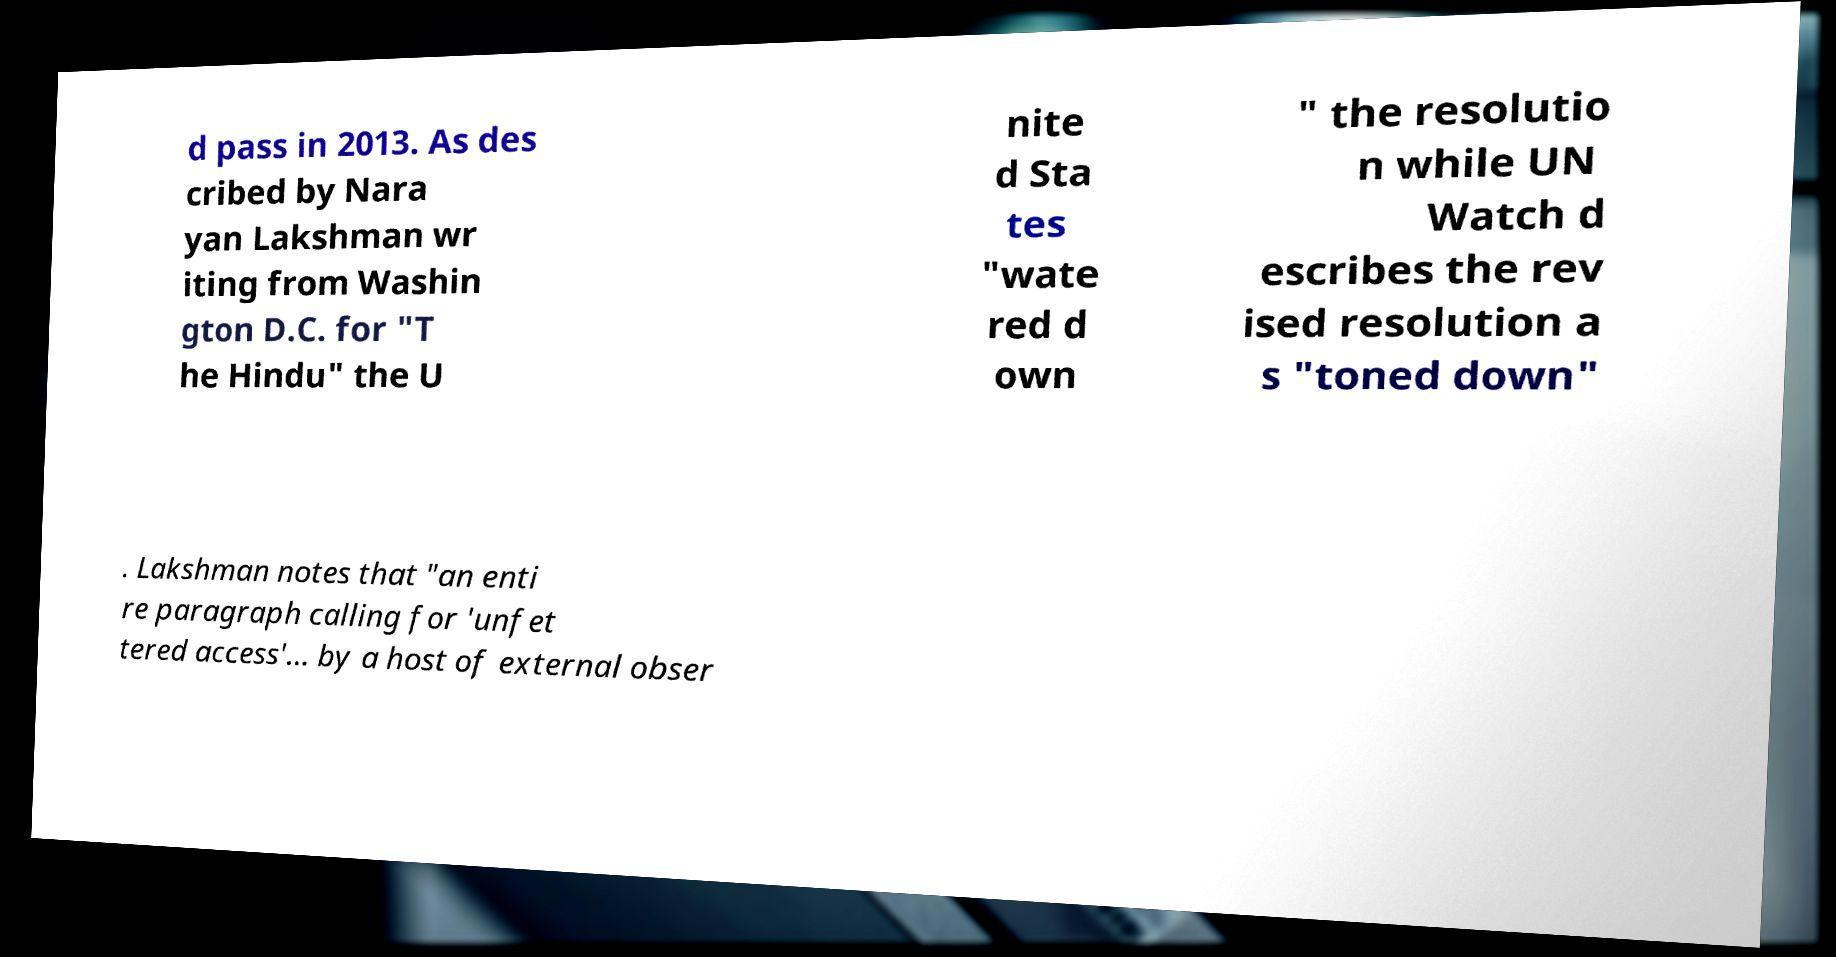Can you read and provide the text displayed in the image?This photo seems to have some interesting text. Can you extract and type it out for me? d pass in 2013. As des cribed by Nara yan Lakshman wr iting from Washin gton D.C. for "T he Hindu" the U nite d Sta tes "wate red d own " the resolutio n while UN Watch d escribes the rev ised resolution a s "toned down" . Lakshman notes that "an enti re paragraph calling for 'unfet tered access'... by a host of external obser 